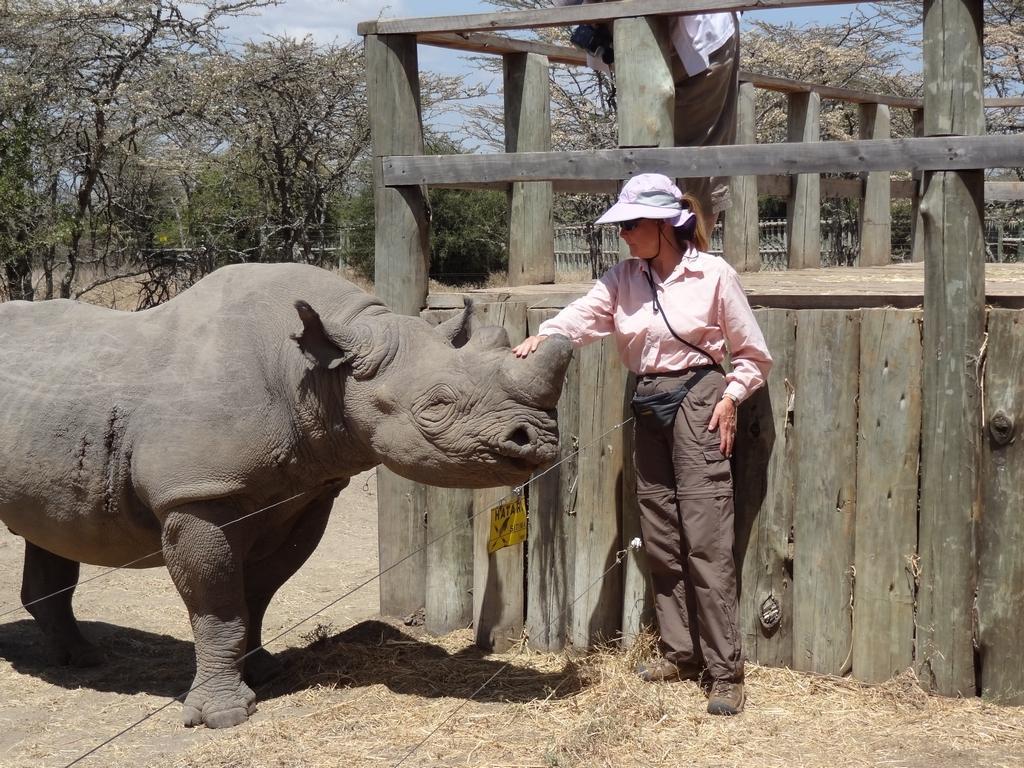In one or two sentences, can you explain what this image depicts? In this picture we can see a rhinoceros and a person are standing, at the bottom there is grass, in the background we can see trees, on the right side we can see wood, there is the sky at the top of the picture. 